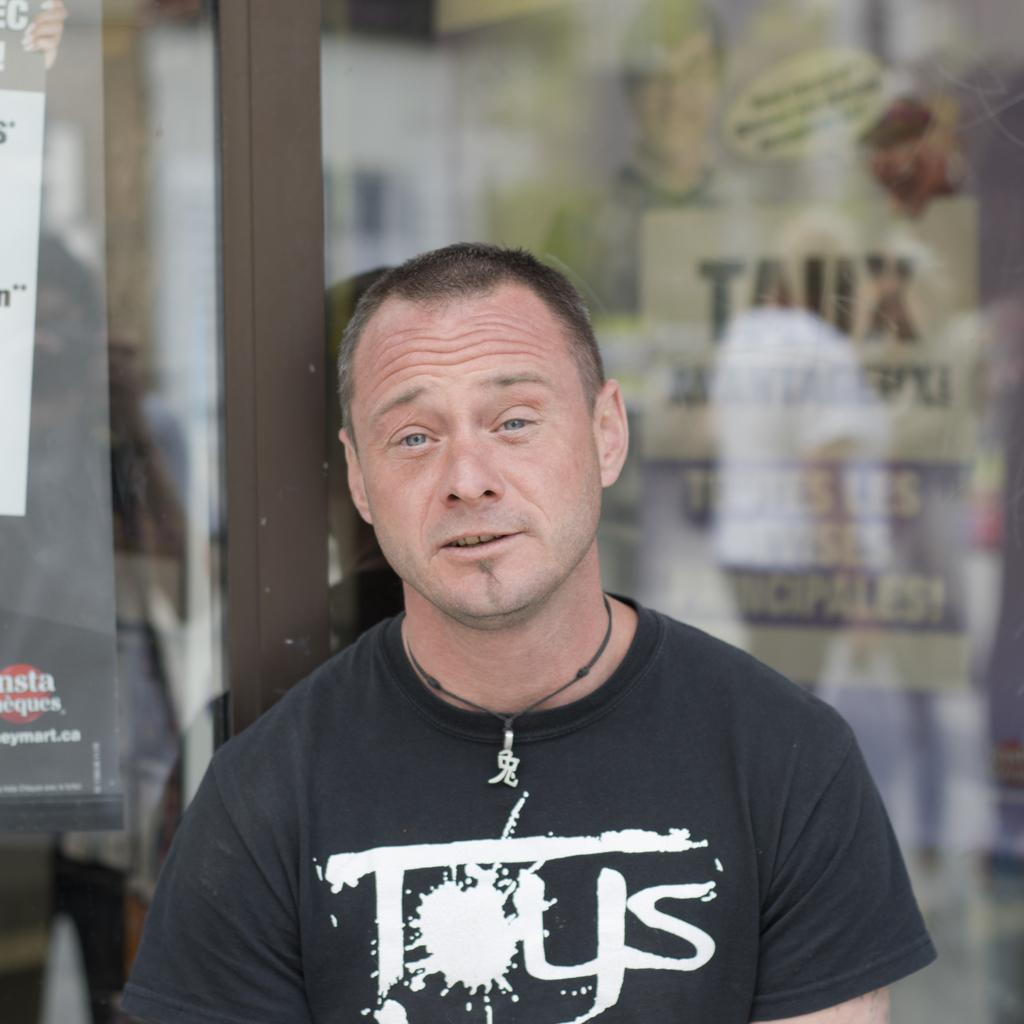What is the person in the image doing? The person is standing in front of a glass door. What can be seen in the background of the image? There are posters in the background of the image. What do the posters contain? The posters contain pictures and text. What type of alley can be seen in the image? There is no alley present in the image. What emotion is being expressed by the person in the image? The image does not convey any specific emotion, as the person's facial expression is not visible. 